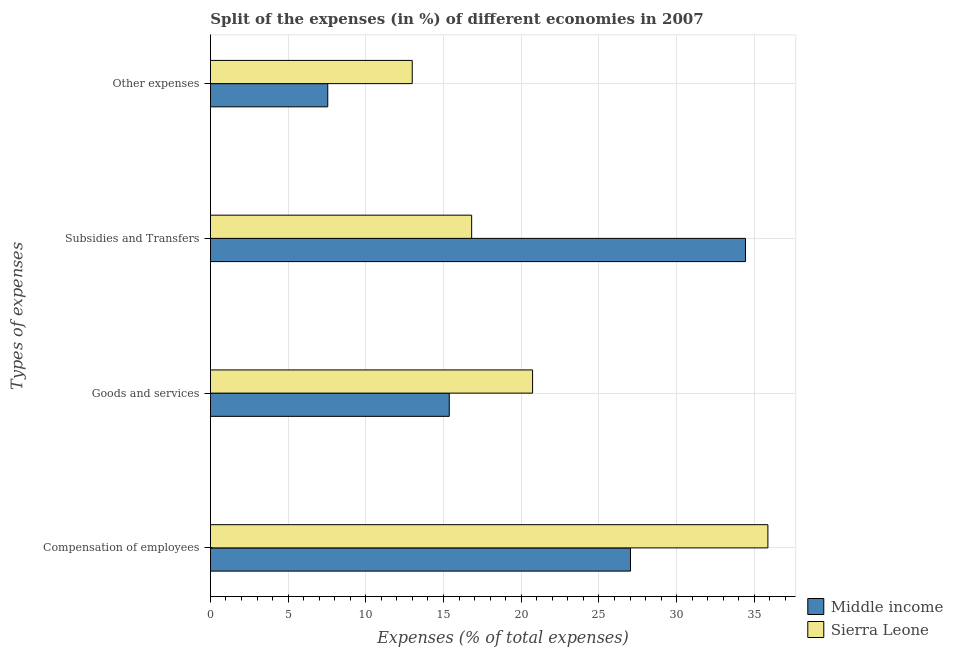How many different coloured bars are there?
Provide a short and direct response. 2. How many groups of bars are there?
Ensure brevity in your answer.  4. Are the number of bars on each tick of the Y-axis equal?
Ensure brevity in your answer.  Yes. What is the label of the 1st group of bars from the top?
Provide a succinct answer. Other expenses. What is the percentage of amount spent on other expenses in Middle income?
Provide a succinct answer. 7.55. Across all countries, what is the maximum percentage of amount spent on subsidies?
Ensure brevity in your answer.  34.43. Across all countries, what is the minimum percentage of amount spent on other expenses?
Provide a succinct answer. 7.55. In which country was the percentage of amount spent on other expenses maximum?
Your response must be concise. Sierra Leone. In which country was the percentage of amount spent on subsidies minimum?
Your answer should be very brief. Sierra Leone. What is the total percentage of amount spent on subsidies in the graph?
Your answer should be compact. 51.24. What is the difference between the percentage of amount spent on compensation of employees in Sierra Leone and that in Middle income?
Provide a short and direct response. 8.84. What is the difference between the percentage of amount spent on other expenses in Middle income and the percentage of amount spent on goods and services in Sierra Leone?
Make the answer very short. -13.18. What is the average percentage of amount spent on other expenses per country?
Ensure brevity in your answer.  10.27. What is the difference between the percentage of amount spent on subsidies and percentage of amount spent on compensation of employees in Sierra Leone?
Provide a succinct answer. -19.06. In how many countries, is the percentage of amount spent on other expenses greater than 18 %?
Ensure brevity in your answer.  0. What is the ratio of the percentage of amount spent on compensation of employees in Sierra Leone to that in Middle income?
Your response must be concise. 1.33. Is the percentage of amount spent on subsidies in Middle income less than that in Sierra Leone?
Offer a very short reply. No. Is the difference between the percentage of amount spent on subsidies in Middle income and Sierra Leone greater than the difference between the percentage of amount spent on goods and services in Middle income and Sierra Leone?
Give a very brief answer. Yes. What is the difference between the highest and the second highest percentage of amount spent on other expenses?
Keep it short and to the point. 5.43. What is the difference between the highest and the lowest percentage of amount spent on goods and services?
Offer a terse response. 5.36. In how many countries, is the percentage of amount spent on subsidies greater than the average percentage of amount spent on subsidies taken over all countries?
Make the answer very short. 1. Is it the case that in every country, the sum of the percentage of amount spent on goods and services and percentage of amount spent on other expenses is greater than the sum of percentage of amount spent on subsidies and percentage of amount spent on compensation of employees?
Your response must be concise. No. What does the 2nd bar from the top in Goods and services represents?
Offer a very short reply. Middle income. How many countries are there in the graph?
Offer a very short reply. 2. What is the difference between two consecutive major ticks on the X-axis?
Offer a terse response. 5. Are the values on the major ticks of X-axis written in scientific E-notation?
Give a very brief answer. No. Does the graph contain grids?
Keep it short and to the point. Yes. How many legend labels are there?
Your response must be concise. 2. How are the legend labels stacked?
Your answer should be compact. Vertical. What is the title of the graph?
Offer a terse response. Split of the expenses (in %) of different economies in 2007. Does "Brazil" appear as one of the legend labels in the graph?
Provide a succinct answer. No. What is the label or title of the X-axis?
Your answer should be compact. Expenses (% of total expenses). What is the label or title of the Y-axis?
Give a very brief answer. Types of expenses. What is the Expenses (% of total expenses) in Middle income in Compensation of employees?
Provide a succinct answer. 27.03. What is the Expenses (% of total expenses) of Sierra Leone in Compensation of employees?
Your answer should be very brief. 35.87. What is the Expenses (% of total expenses) of Middle income in Goods and services?
Offer a terse response. 15.37. What is the Expenses (% of total expenses) of Sierra Leone in Goods and services?
Your answer should be very brief. 20.73. What is the Expenses (% of total expenses) in Middle income in Subsidies and Transfers?
Give a very brief answer. 34.43. What is the Expenses (% of total expenses) of Sierra Leone in Subsidies and Transfers?
Offer a terse response. 16.81. What is the Expenses (% of total expenses) in Middle income in Other expenses?
Keep it short and to the point. 7.55. What is the Expenses (% of total expenses) of Sierra Leone in Other expenses?
Ensure brevity in your answer.  12.99. Across all Types of expenses, what is the maximum Expenses (% of total expenses) of Middle income?
Offer a very short reply. 34.43. Across all Types of expenses, what is the maximum Expenses (% of total expenses) in Sierra Leone?
Give a very brief answer. 35.87. Across all Types of expenses, what is the minimum Expenses (% of total expenses) of Middle income?
Offer a very short reply. 7.55. Across all Types of expenses, what is the minimum Expenses (% of total expenses) in Sierra Leone?
Provide a short and direct response. 12.99. What is the total Expenses (% of total expenses) in Middle income in the graph?
Your answer should be compact. 84.39. What is the total Expenses (% of total expenses) in Sierra Leone in the graph?
Your answer should be very brief. 86.4. What is the difference between the Expenses (% of total expenses) of Middle income in Compensation of employees and that in Goods and services?
Offer a very short reply. 11.66. What is the difference between the Expenses (% of total expenses) in Sierra Leone in Compensation of employees and that in Goods and services?
Provide a succinct answer. 15.14. What is the difference between the Expenses (% of total expenses) of Middle income in Compensation of employees and that in Subsidies and Transfers?
Your answer should be very brief. -7.4. What is the difference between the Expenses (% of total expenses) of Sierra Leone in Compensation of employees and that in Subsidies and Transfers?
Ensure brevity in your answer.  19.06. What is the difference between the Expenses (% of total expenses) of Middle income in Compensation of employees and that in Other expenses?
Provide a succinct answer. 19.48. What is the difference between the Expenses (% of total expenses) of Sierra Leone in Compensation of employees and that in Other expenses?
Offer a very short reply. 22.89. What is the difference between the Expenses (% of total expenses) in Middle income in Goods and services and that in Subsidies and Transfers?
Your answer should be compact. -19.06. What is the difference between the Expenses (% of total expenses) in Sierra Leone in Goods and services and that in Subsidies and Transfers?
Offer a terse response. 3.92. What is the difference between the Expenses (% of total expenses) in Middle income in Goods and services and that in Other expenses?
Offer a very short reply. 7.82. What is the difference between the Expenses (% of total expenses) in Sierra Leone in Goods and services and that in Other expenses?
Provide a succinct answer. 7.74. What is the difference between the Expenses (% of total expenses) of Middle income in Subsidies and Transfers and that in Other expenses?
Give a very brief answer. 26.88. What is the difference between the Expenses (% of total expenses) of Sierra Leone in Subsidies and Transfers and that in Other expenses?
Your answer should be very brief. 3.82. What is the difference between the Expenses (% of total expenses) in Middle income in Compensation of employees and the Expenses (% of total expenses) in Sierra Leone in Goods and services?
Your answer should be compact. 6.3. What is the difference between the Expenses (% of total expenses) of Middle income in Compensation of employees and the Expenses (% of total expenses) of Sierra Leone in Subsidies and Transfers?
Your response must be concise. 10.22. What is the difference between the Expenses (% of total expenses) in Middle income in Compensation of employees and the Expenses (% of total expenses) in Sierra Leone in Other expenses?
Ensure brevity in your answer.  14.04. What is the difference between the Expenses (% of total expenses) of Middle income in Goods and services and the Expenses (% of total expenses) of Sierra Leone in Subsidies and Transfers?
Make the answer very short. -1.44. What is the difference between the Expenses (% of total expenses) of Middle income in Goods and services and the Expenses (% of total expenses) of Sierra Leone in Other expenses?
Keep it short and to the point. 2.38. What is the difference between the Expenses (% of total expenses) in Middle income in Subsidies and Transfers and the Expenses (% of total expenses) in Sierra Leone in Other expenses?
Your answer should be compact. 21.44. What is the average Expenses (% of total expenses) of Middle income per Types of expenses?
Provide a short and direct response. 21.1. What is the average Expenses (% of total expenses) of Sierra Leone per Types of expenses?
Offer a very short reply. 21.6. What is the difference between the Expenses (% of total expenses) of Middle income and Expenses (% of total expenses) of Sierra Leone in Compensation of employees?
Give a very brief answer. -8.84. What is the difference between the Expenses (% of total expenses) of Middle income and Expenses (% of total expenses) of Sierra Leone in Goods and services?
Offer a terse response. -5.36. What is the difference between the Expenses (% of total expenses) of Middle income and Expenses (% of total expenses) of Sierra Leone in Subsidies and Transfers?
Offer a very short reply. 17.62. What is the difference between the Expenses (% of total expenses) in Middle income and Expenses (% of total expenses) in Sierra Leone in Other expenses?
Provide a short and direct response. -5.43. What is the ratio of the Expenses (% of total expenses) of Middle income in Compensation of employees to that in Goods and services?
Offer a terse response. 1.76. What is the ratio of the Expenses (% of total expenses) of Sierra Leone in Compensation of employees to that in Goods and services?
Make the answer very short. 1.73. What is the ratio of the Expenses (% of total expenses) in Middle income in Compensation of employees to that in Subsidies and Transfers?
Offer a very short reply. 0.79. What is the ratio of the Expenses (% of total expenses) of Sierra Leone in Compensation of employees to that in Subsidies and Transfers?
Your answer should be very brief. 2.13. What is the ratio of the Expenses (% of total expenses) in Middle income in Compensation of employees to that in Other expenses?
Keep it short and to the point. 3.58. What is the ratio of the Expenses (% of total expenses) of Sierra Leone in Compensation of employees to that in Other expenses?
Provide a succinct answer. 2.76. What is the ratio of the Expenses (% of total expenses) in Middle income in Goods and services to that in Subsidies and Transfers?
Your response must be concise. 0.45. What is the ratio of the Expenses (% of total expenses) of Sierra Leone in Goods and services to that in Subsidies and Transfers?
Offer a very short reply. 1.23. What is the ratio of the Expenses (% of total expenses) in Middle income in Goods and services to that in Other expenses?
Your answer should be very brief. 2.04. What is the ratio of the Expenses (% of total expenses) in Sierra Leone in Goods and services to that in Other expenses?
Give a very brief answer. 1.6. What is the ratio of the Expenses (% of total expenses) of Middle income in Subsidies and Transfers to that in Other expenses?
Make the answer very short. 4.56. What is the ratio of the Expenses (% of total expenses) of Sierra Leone in Subsidies and Transfers to that in Other expenses?
Your answer should be very brief. 1.29. What is the difference between the highest and the second highest Expenses (% of total expenses) of Middle income?
Provide a succinct answer. 7.4. What is the difference between the highest and the second highest Expenses (% of total expenses) in Sierra Leone?
Your response must be concise. 15.14. What is the difference between the highest and the lowest Expenses (% of total expenses) of Middle income?
Give a very brief answer. 26.88. What is the difference between the highest and the lowest Expenses (% of total expenses) of Sierra Leone?
Give a very brief answer. 22.89. 